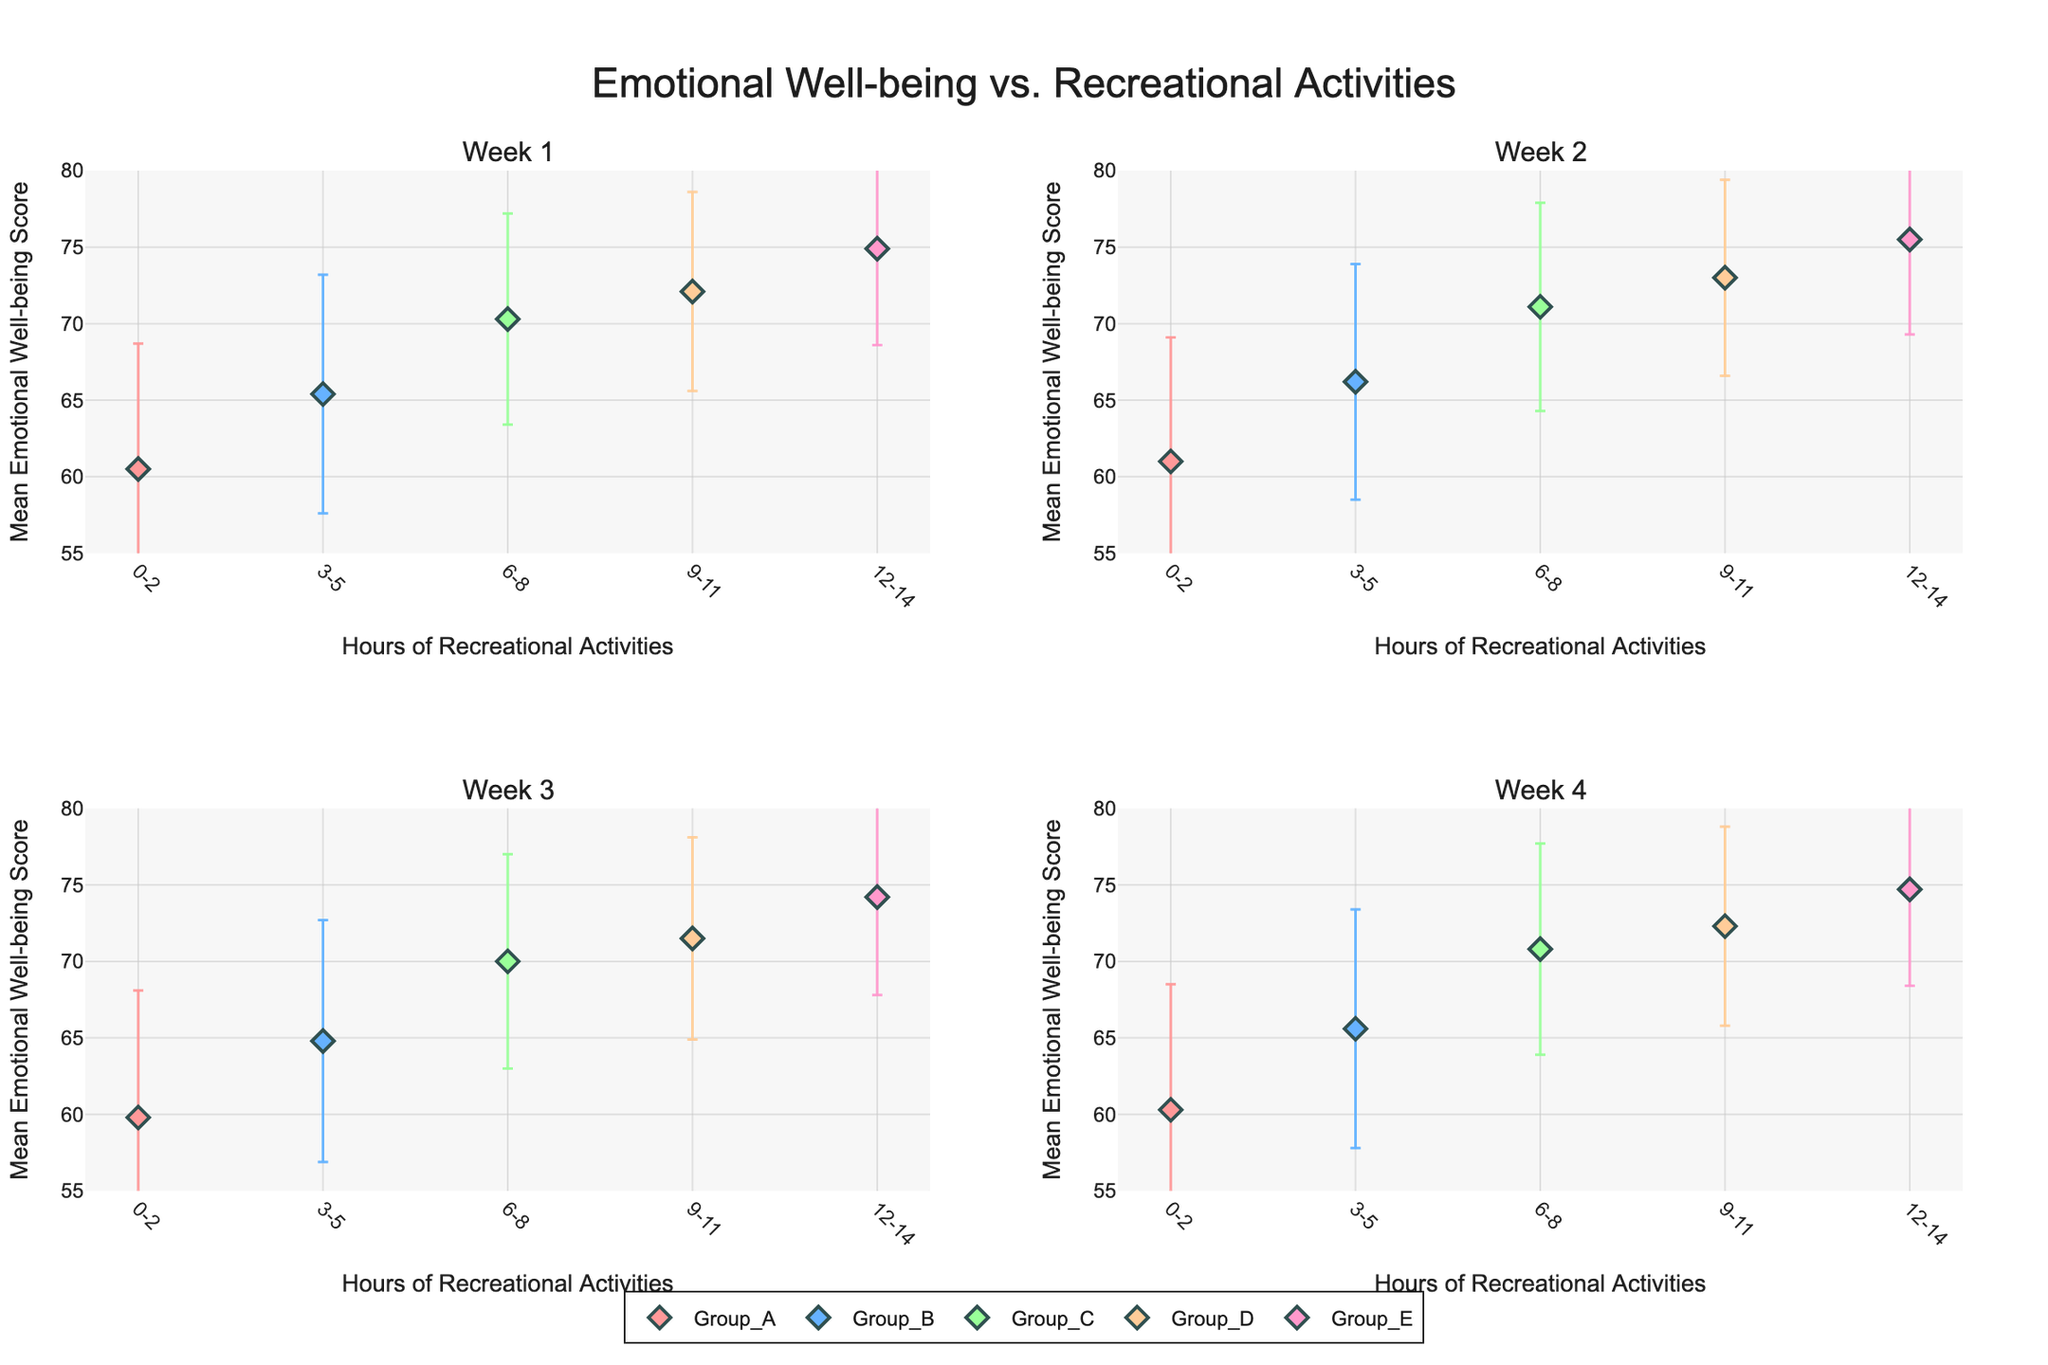What's the title of the figure? The title is usually placed at the top of the figure. In this case, based on the provided code, it should be something descriptive.
Answer: Emotional Well-being vs. Recreational Activities How many groups are compared in each week's subplot? To find the number of groups, look at the different markers shown in each subplot. There are distinct markers for each group.
Answer: 5 Which group has the lowest mean emotional well-being score in Week 1? Find the subplot for Week 1, and then identify the marker with the lowest position on the y-axis. This should correspond to Group A.
Answer: Group_A What is the range of the y-axis for emotional well-being scores? Look at the y-axis label and the values ranging from the minimum to maximum plotted data. This can be verified through the axis ticks.
Answer: 55 to 80 Which group shows the highest improvement in mean emotional well-being scores from Week 1 to Week 4? Calculate the difference in mean emotional well-being scores from Week 1 to Week 4 for each group. The group with the maximum positive change is Group D (72.1 to 72.3) compared to others.
Answer: Group_D Do any groups in Week 3 show a decline in mean emotional well-being score compared to Week 2? Compare the mean scores of Week 3 to Week 2 for each group. The groups that have a lower mean score in Week 3 are Groups A, B, C, and D.
Answer: Yes What is the mean emotional well-being score for Group E across all weeks? Sum the mean emotional well-being scores for Group E across all weeks and then divide by the number of weeks. (74.9 + 75.5 + 74.2 + 74.7) / 4.
Answer: 74.83 How do the error bars for Group C change over the weeks? Look at the length of the error bars for Group C in each subplot. Group C error bars remain relatively consistent across weeks, without significant changes.
Answer: Consistent In Week 2, which group has the smallest error margin and what is that value? Identify the error bar with the shortest length in Week 2's subplot and read its numerical value. Group E shows the smallest with 6.2.
Answer: Group_E, 6.2 Which group shows the least variance in emotional well-being scores over the four weeks? Compare the standard deviations of each group across all weeks. Group E consistently has lower standard deviations, indicating less variance.
Answer: Group_E 